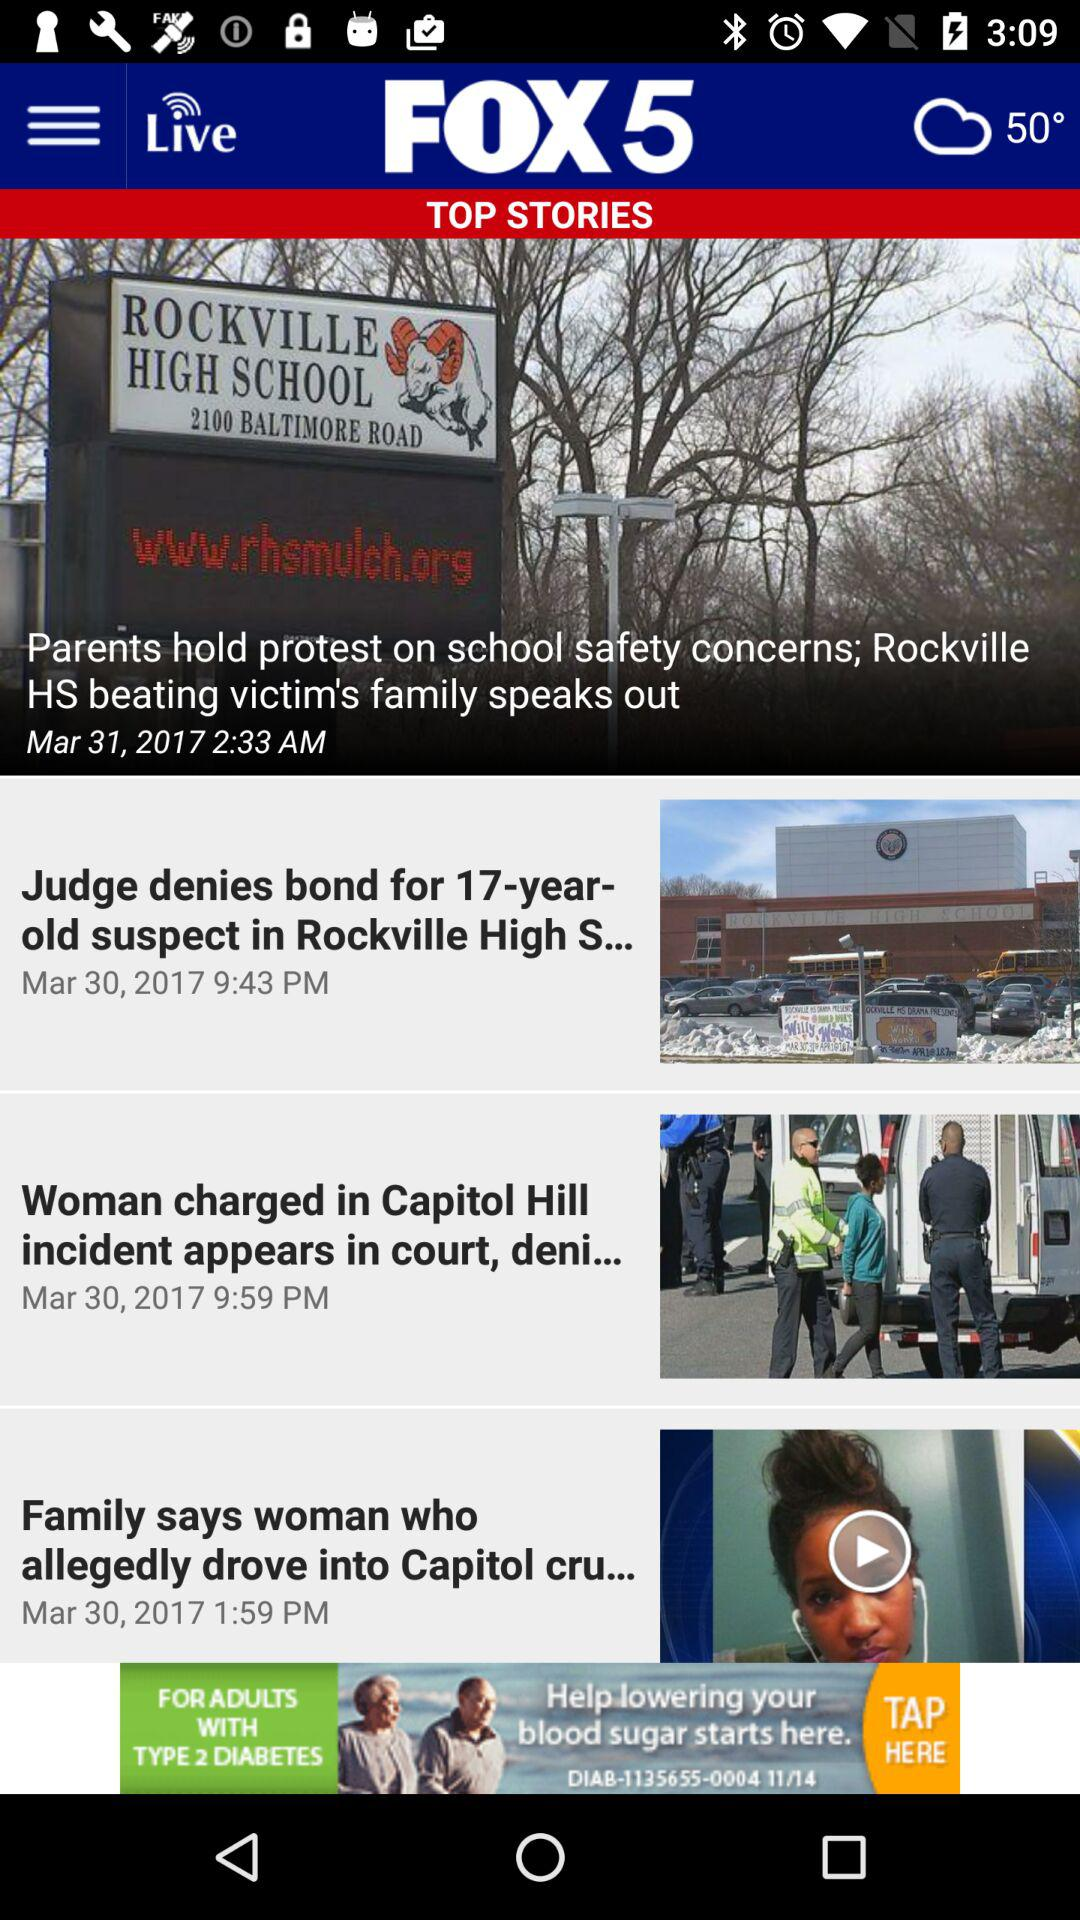How is the weather? The weather is cloudy. 